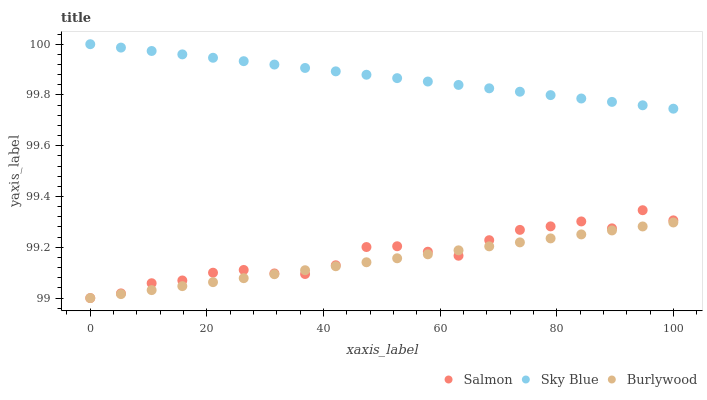Does Burlywood have the minimum area under the curve?
Answer yes or no. Yes. Does Sky Blue have the maximum area under the curve?
Answer yes or no. Yes. Does Salmon have the minimum area under the curve?
Answer yes or no. No. Does Salmon have the maximum area under the curve?
Answer yes or no. No. Is Sky Blue the smoothest?
Answer yes or no. Yes. Is Salmon the roughest?
Answer yes or no. Yes. Is Salmon the smoothest?
Answer yes or no. No. Is Sky Blue the roughest?
Answer yes or no. No. Does Burlywood have the lowest value?
Answer yes or no. Yes. Does Sky Blue have the lowest value?
Answer yes or no. No. Does Sky Blue have the highest value?
Answer yes or no. Yes. Does Salmon have the highest value?
Answer yes or no. No. Is Burlywood less than Sky Blue?
Answer yes or no. Yes. Is Sky Blue greater than Salmon?
Answer yes or no. Yes. Does Burlywood intersect Salmon?
Answer yes or no. Yes. Is Burlywood less than Salmon?
Answer yes or no. No. Is Burlywood greater than Salmon?
Answer yes or no. No. Does Burlywood intersect Sky Blue?
Answer yes or no. No. 